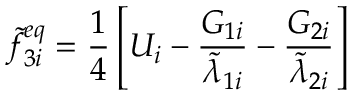Convert formula to latex. <formula><loc_0><loc_0><loc_500><loc_500>\widetilde { f } _ { 3 i } ^ { e q } = \frac { 1 } { 4 } \left [ U _ { i } - \frac { G _ { 1 i } } { \widetilde { \lambda } _ { 1 i } } - \frac { G _ { 2 i } } { \widetilde { \lambda } _ { 2 i } } \right ]</formula> 